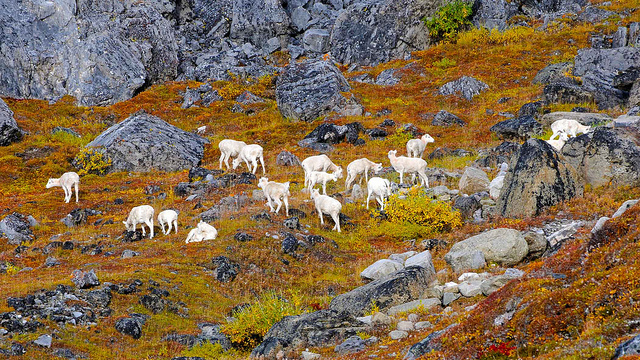What might be the reason for gathering in such a large group? Mountain goats often gather in groups that can facilitate social interactions and provide safety in numbers. A large group may also indicate plentiful resources or a seasonal migration pattern for breeding or foraging. Do these animals have natural predators in such an environment? Yes, mountain goats face predation threats from large carnivores like bears and mountain lions, as well as aerial predators like golden eagles, especially when it comes to younger or weaker individuals. 